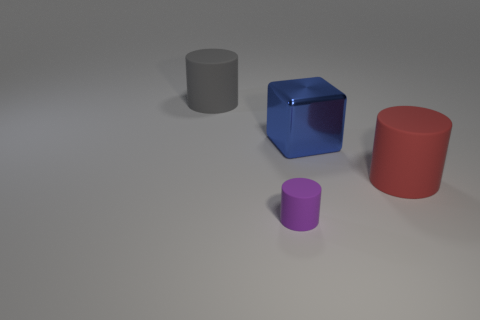Subtract all big cylinders. How many cylinders are left? 1 Add 2 brown spheres. How many objects exist? 6 Subtract all blocks. How many objects are left? 3 Subtract 1 cylinders. How many cylinders are left? 2 Subtract 0 brown cubes. How many objects are left? 4 Subtract all yellow cylinders. Subtract all cyan blocks. How many cylinders are left? 3 Subtract all small cyan blocks. Subtract all big gray objects. How many objects are left? 3 Add 2 large blue things. How many large blue things are left? 3 Add 1 big brown cubes. How many big brown cubes exist? 1 